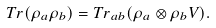<formula> <loc_0><loc_0><loc_500><loc_500>T r ( \rho _ { a } \rho _ { b } ) = T r _ { a b } ( \rho _ { a } \otimes \rho _ { b } V ) .</formula> 